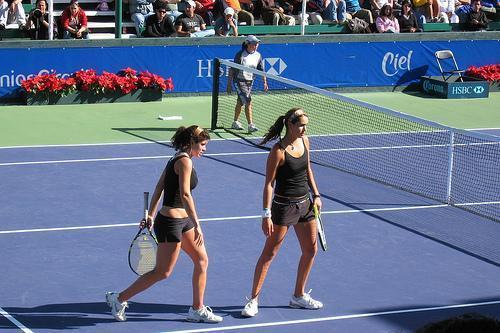How many people are playing tennis?
Give a very brief answer. 2. 